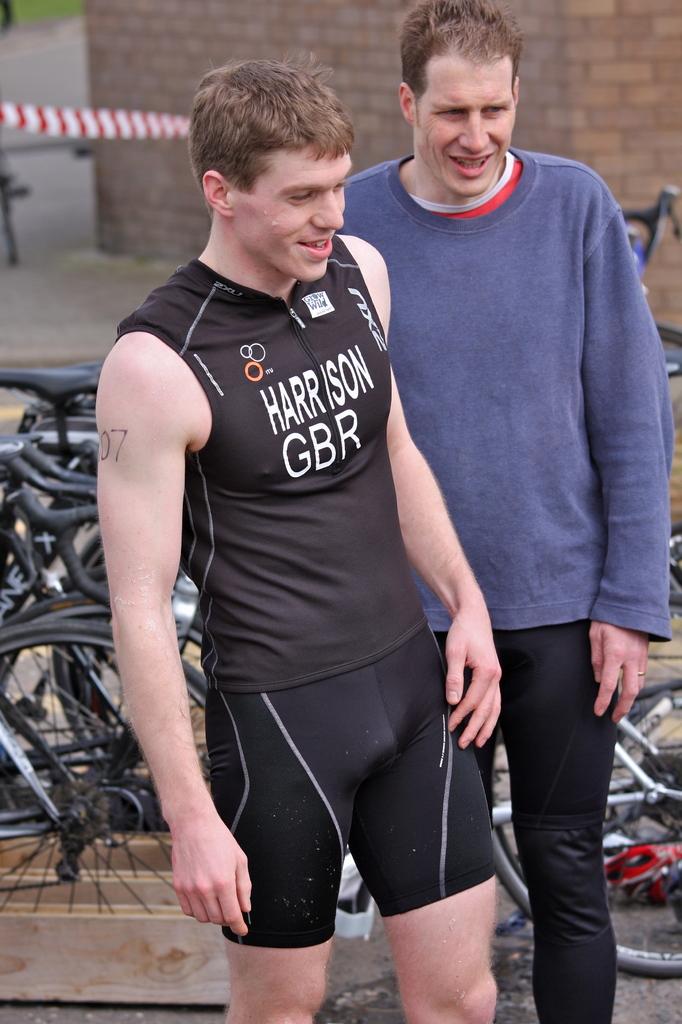What town in endorsed on the runners chest>?
Your answer should be compact. Harrison. What are the initials?
Your response must be concise. Gbr. 